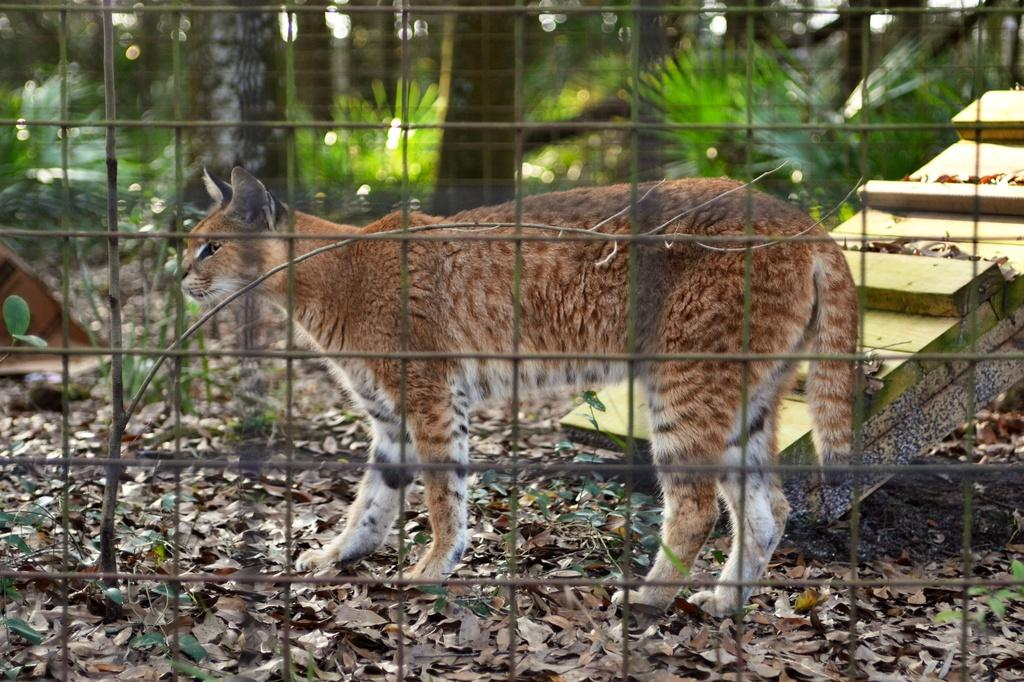What is the main subject in the center of the image? There is a cat in the center of the image. What is located in the foreground of the image? There is a mesh in the foreground. What can be seen in the background of the image? There are trees in the background. Where is the faucet located in the image? There is no faucet present in the image. What type of animal is standing next to the cat in the image? There is no other animal present in the image besides the cat. 